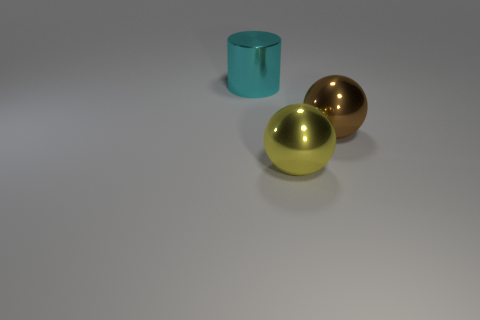Can you describe the texture appearance of the objects? Certainly! The objects exhibit smooth and reflective surfaces, suggestive of a polished metallic texture. The light highlights and subtle reflections suggest they're highly glossy. 